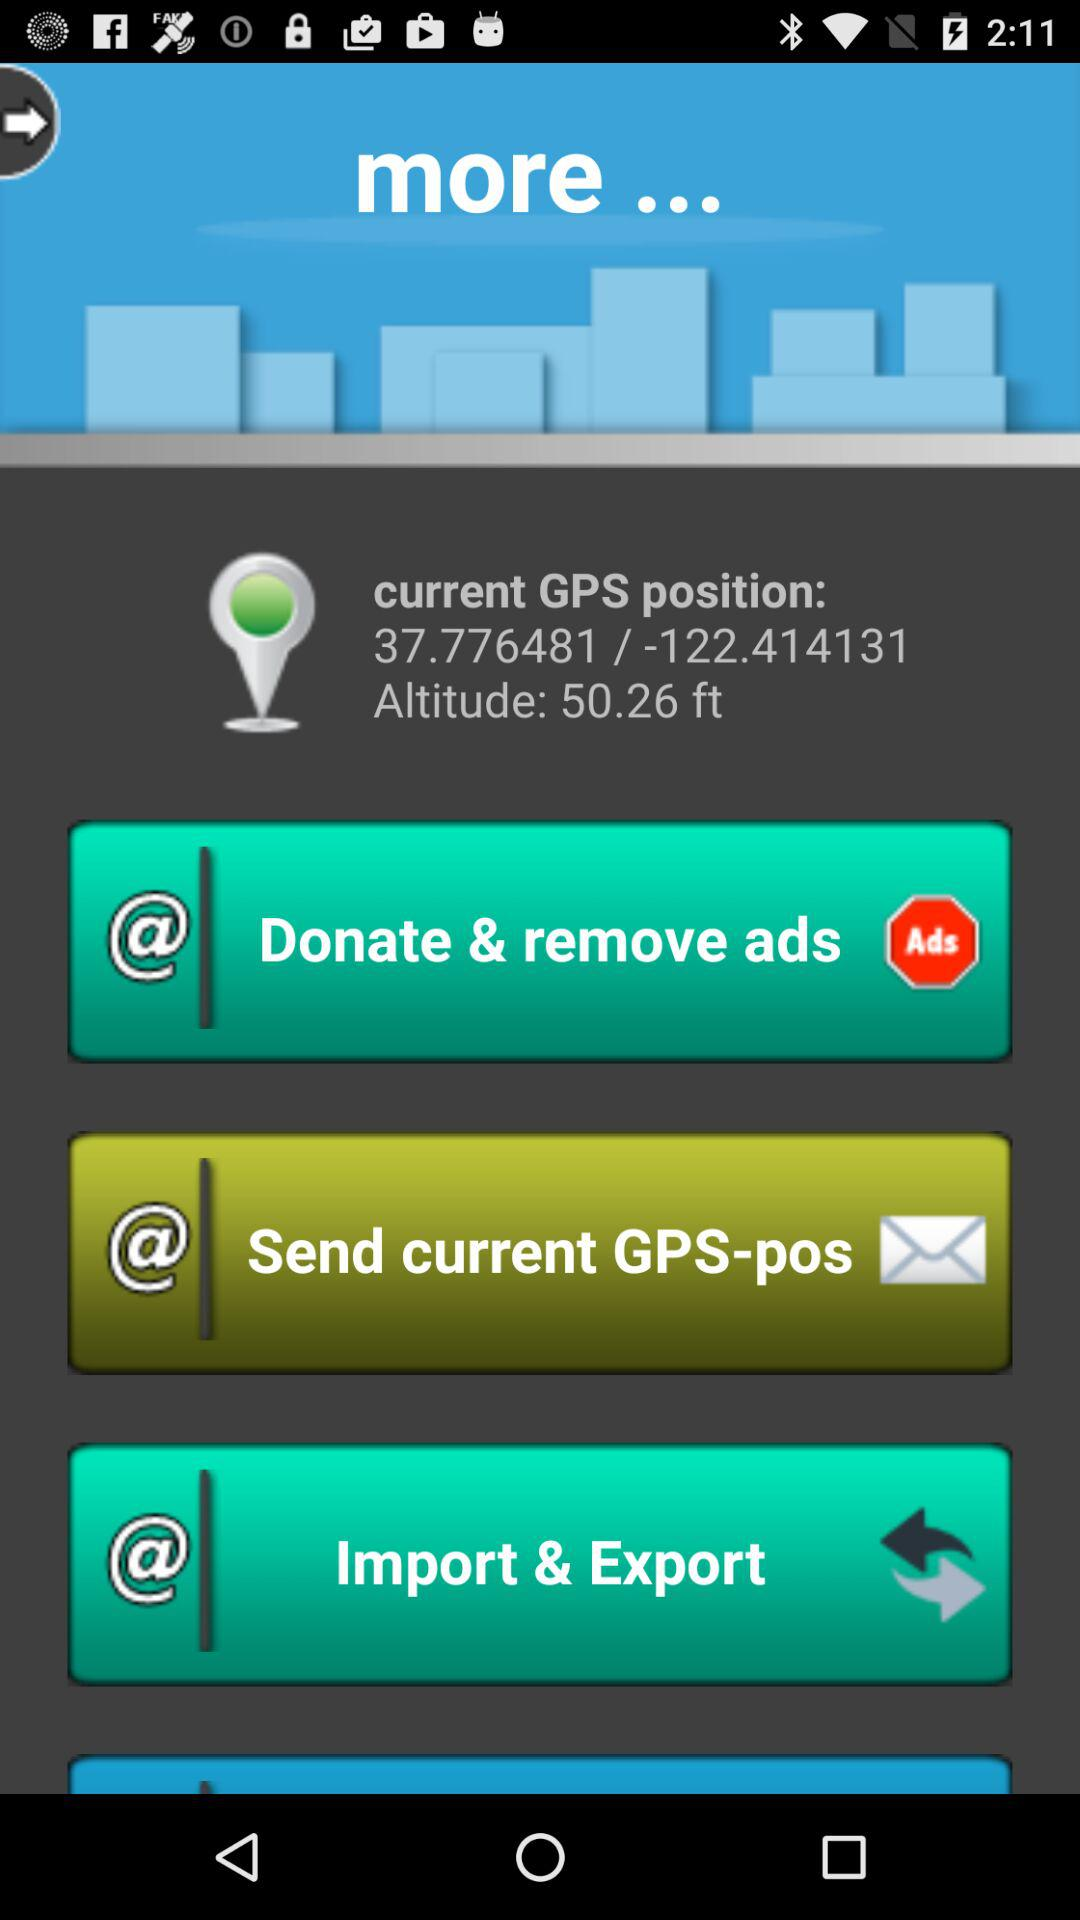How many feet above sea level is the current GPS position?
Answer the question using a single word or phrase. 50.26 